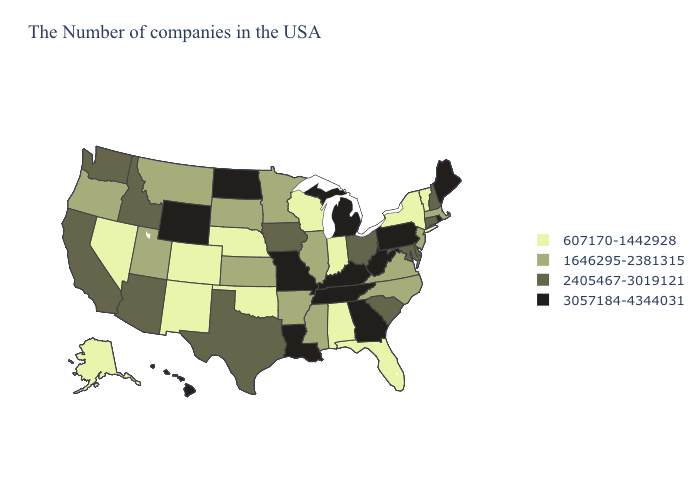Does the first symbol in the legend represent the smallest category?
Be succinct. Yes. Name the states that have a value in the range 607170-1442928?
Write a very short answer. Vermont, New York, Florida, Indiana, Alabama, Wisconsin, Nebraska, Oklahoma, Colorado, New Mexico, Nevada, Alaska. Name the states that have a value in the range 1646295-2381315?
Give a very brief answer. Massachusetts, New Jersey, Virginia, North Carolina, Illinois, Mississippi, Arkansas, Minnesota, Kansas, South Dakota, Utah, Montana, Oregon. What is the highest value in the Northeast ?
Quick response, please. 3057184-4344031. What is the value of Colorado?
Give a very brief answer. 607170-1442928. Name the states that have a value in the range 607170-1442928?
Give a very brief answer. Vermont, New York, Florida, Indiana, Alabama, Wisconsin, Nebraska, Oklahoma, Colorado, New Mexico, Nevada, Alaska. What is the value of Tennessee?
Keep it brief. 3057184-4344031. What is the value of Arkansas?
Be succinct. 1646295-2381315. Name the states that have a value in the range 2405467-3019121?
Quick response, please. New Hampshire, Connecticut, Delaware, Maryland, South Carolina, Ohio, Iowa, Texas, Arizona, Idaho, California, Washington. Among the states that border West Virginia , does Virginia have the lowest value?
Short answer required. Yes. What is the value of Maine?
Concise answer only. 3057184-4344031. Is the legend a continuous bar?
Be succinct. No. Does Washington have a higher value than Nevada?
Short answer required. Yes. Does Iowa have the highest value in the MidWest?
Keep it brief. No. 